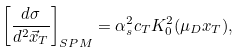Convert formula to latex. <formula><loc_0><loc_0><loc_500><loc_500>\left [ \frac { d \sigma } { d ^ { 2 } { \vec { x } } _ { T } } \right ] _ { S P M } = \alpha _ { s } ^ { 2 } c _ { T } K _ { 0 } ^ { 2 } ( \mu _ { D } x _ { T } ) ,</formula> 